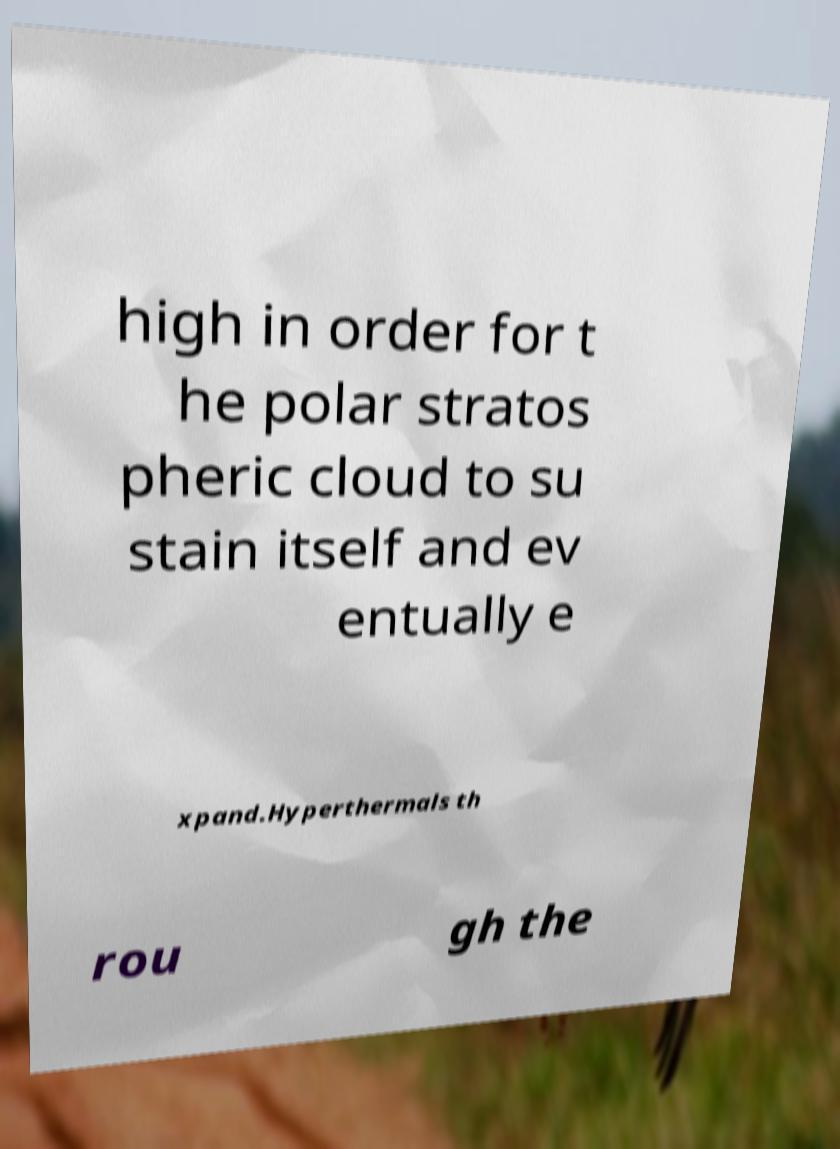For documentation purposes, I need the text within this image transcribed. Could you provide that? high in order for t he polar stratos pheric cloud to su stain itself and ev entually e xpand.Hyperthermals th rou gh the 